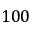<formula> <loc_0><loc_0><loc_500><loc_500>1 0 0</formula> 